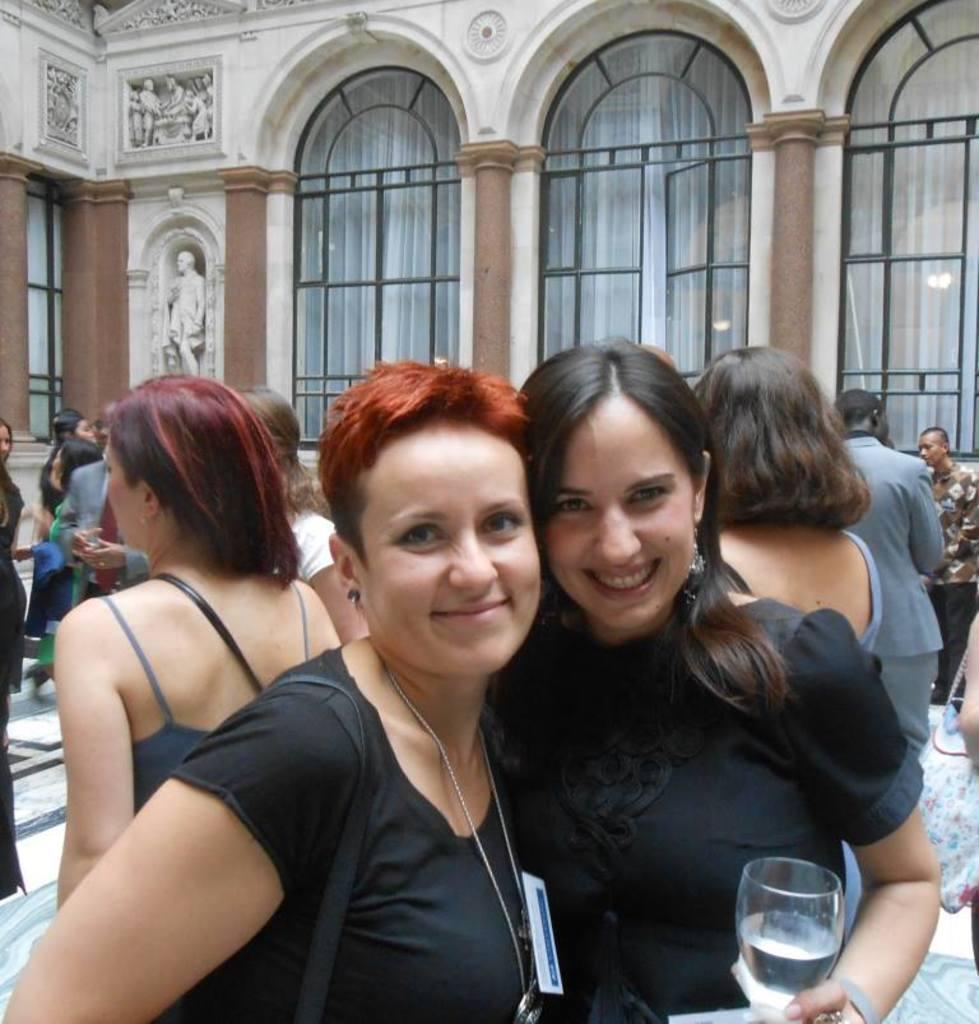In one or two sentences, can you explain what this image depicts? In this image I can see number of people are standing. here I can see two women and smile on their faces. I can also see, she is holding a glass. 